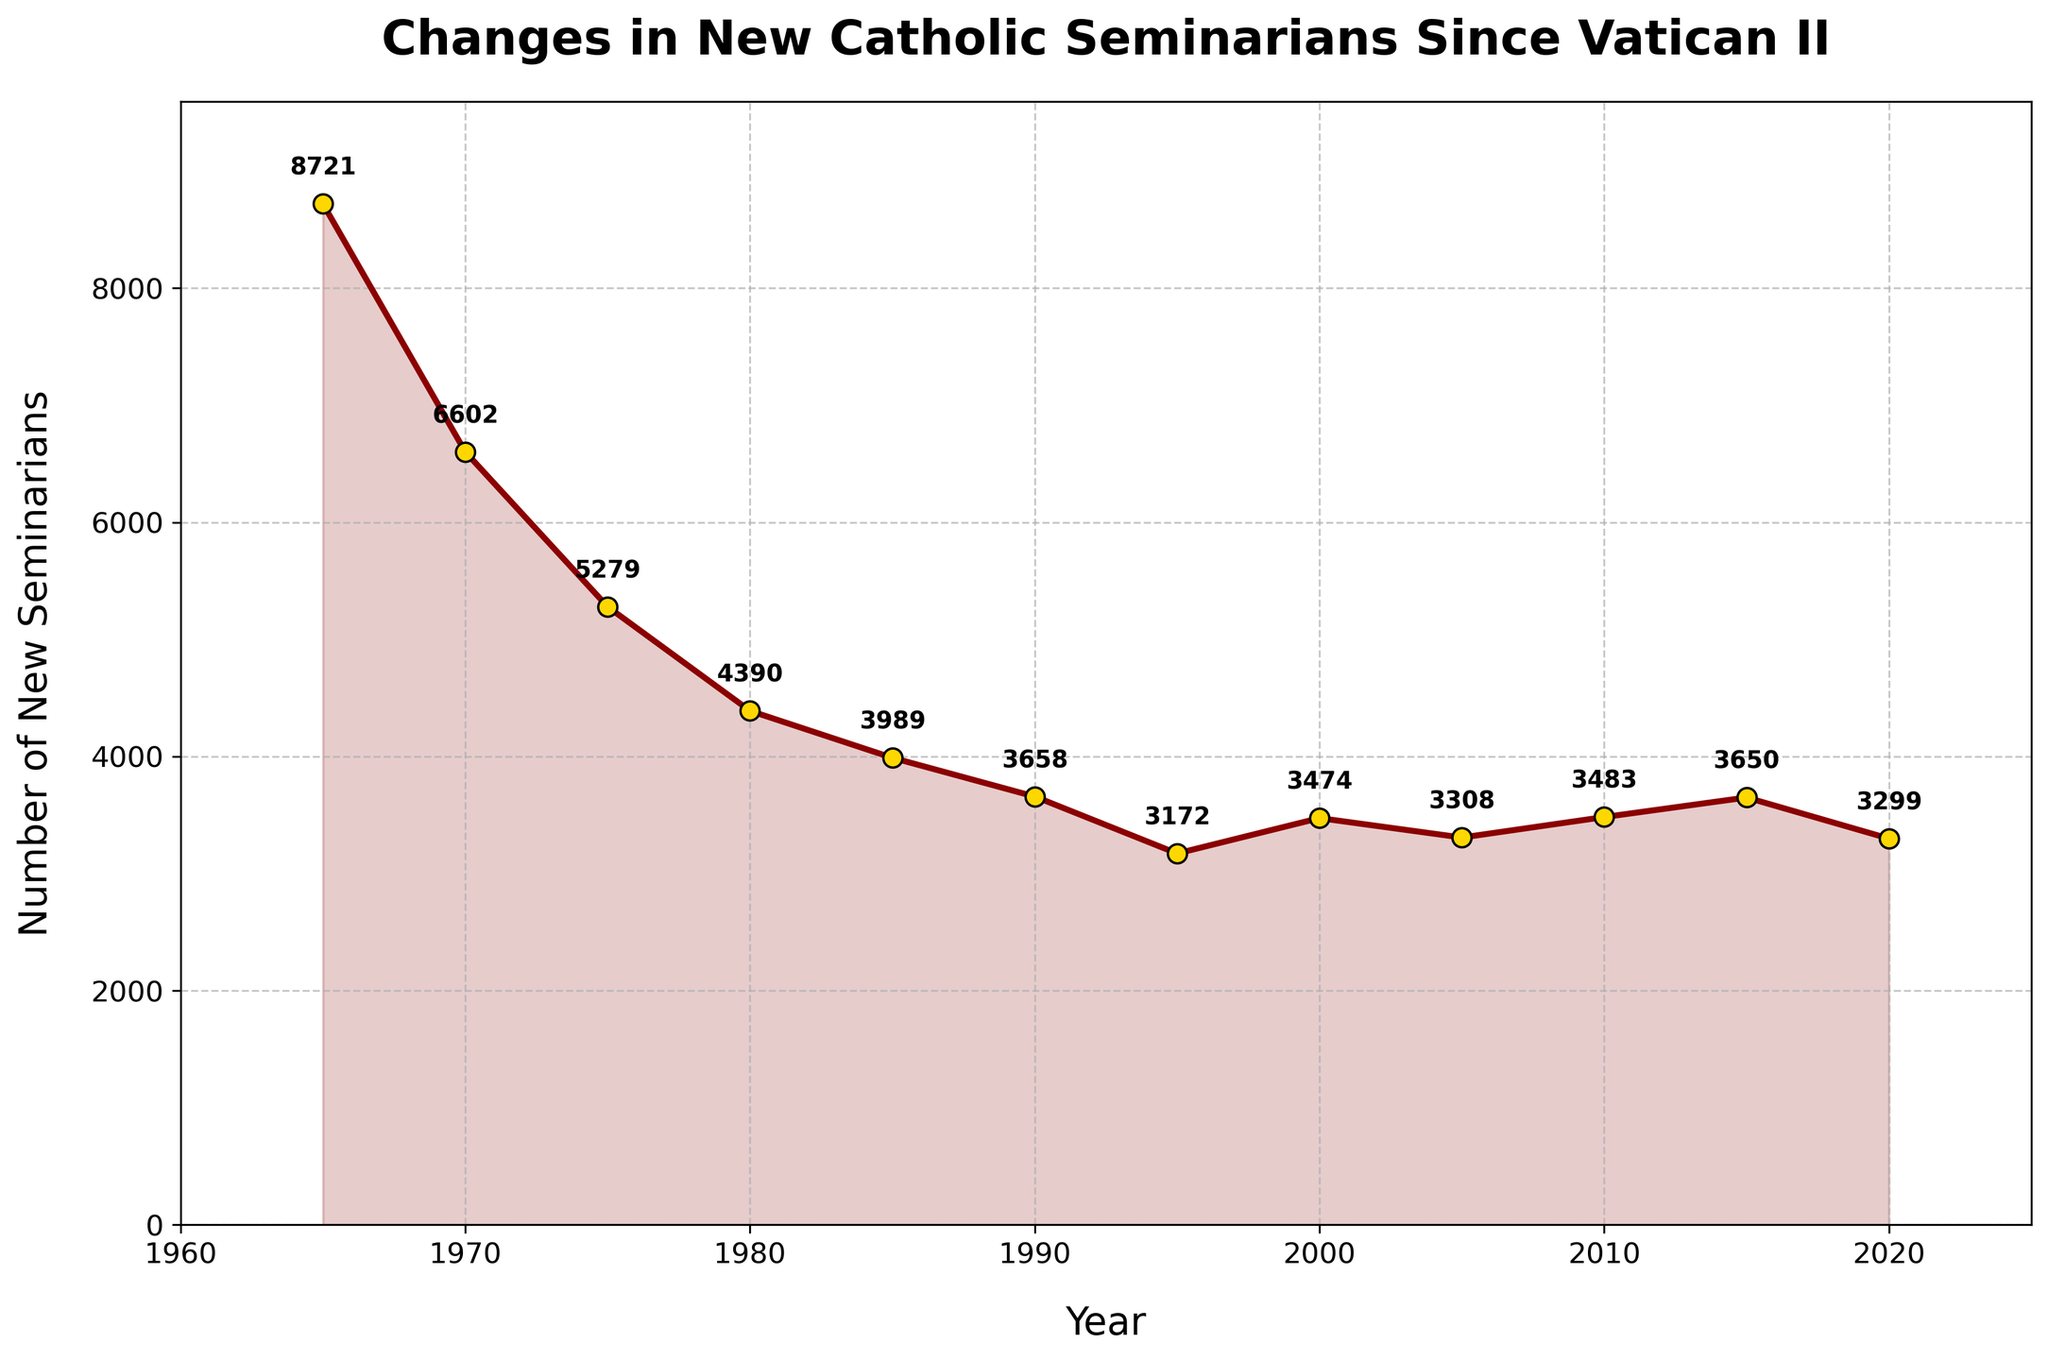what is the general trend in the number of new seminarians from 1965 to 2020? The general trend shows a decline in the number of new seminarians from 1965 to around 2000, followed by some fluctuations and a slight increase before another decline towards 2020.
Answer: Decline overall What is the largest drop in the number of new seminarians between consecutive years? The largest drop occurs between 1965 (8721) and 1970 (6602). The difference is 8721 - 6602 = 2119.
Answer: 2119 In which year did the number of new seminarians first drop below 4000? By observing the plot, the first year where the number dropped below 4000 is 1985 with 3989 new seminarians.
Answer: 1985 How much did the number of new seminarians change between 1980 and 1990? The number in 1980 was 4390, and in 1990 it was 3658. The change is 4390 - 3658 = 732.
Answer: 732 What is the average number of new seminarians per year from 2000 to 2020? Adding the numbers from 2000 to 2020 (3474 + 3308 + 3483 + 3650 + 3299) and then dividing by these 5 years gives the average: (3474 + 3308 + 3483 + 3650 + 3299) / 5 = 3442.8.
Answer: 3442.8 In which decade did the number of new seminarians drop most dramatically overall? The 1960s to 1970s drop from 8721 to 6602 shows a significant drop of 2119 in one decade.
Answer: 1960s to 1970s By how much did the number of new seminarians increase from 1995 to 2000? The numbers are 3172 in 1995 and 3474 in 2000. The increase is 3474 - 3172 = 302.
Answer: 302 Which year had the highest number of new seminarians since 1980? By checking each annotated value since 1980, the highest is 4390 in 1980.
Answer: 1980 